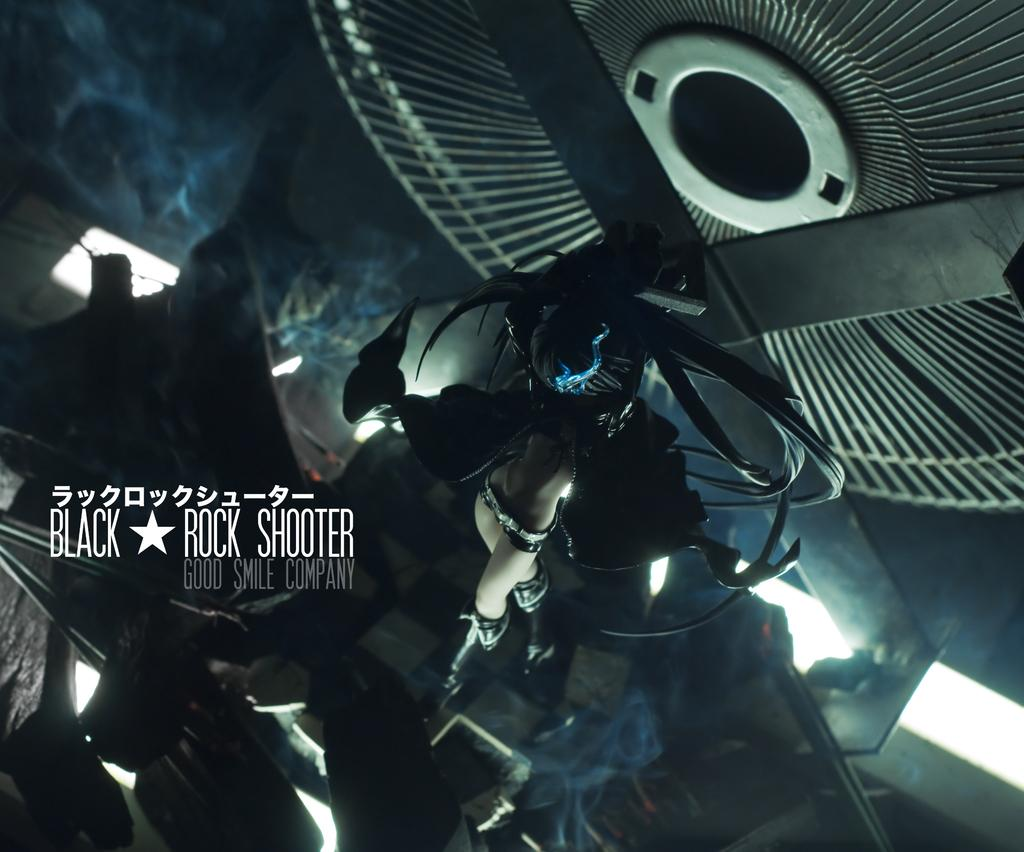<image>
Share a concise interpretation of the image provided. An ad that says Black Rock Shooter and Good Smile Company. 